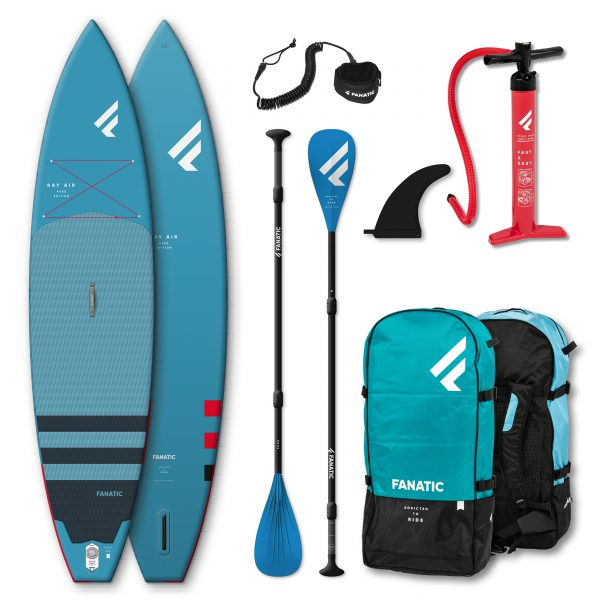What do you think is the story of these items if they were part of a time capsule to be opened in 100 years? If these items were part of a time capsule to be opened in 100 years, they could tell a fascinating story about the popular recreational activities and the design of sporting equipment in the early 21st century. The paddleboards, with their sleek design and vibrant colors, reflect the advancements in materials and technology of the time. The inclusion of the manual pump and coiled leash showcases the practical solutions people used to optimize their outdoor experiences. Opening the time capsule in the future might ignite curiosity and wonder about the lifestyle and leisure activities of the past, offering insights into the evolution of water sports and outdoor recreation over the century. 